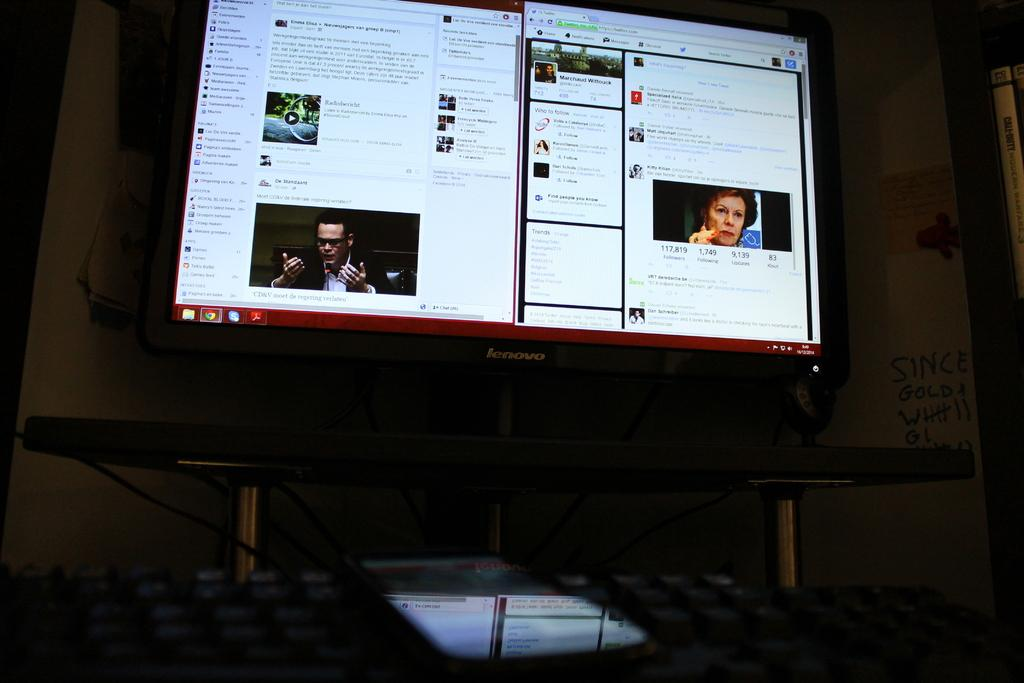<image>
Write a terse but informative summary of the picture. A large size computer monitor made by Lenovo 